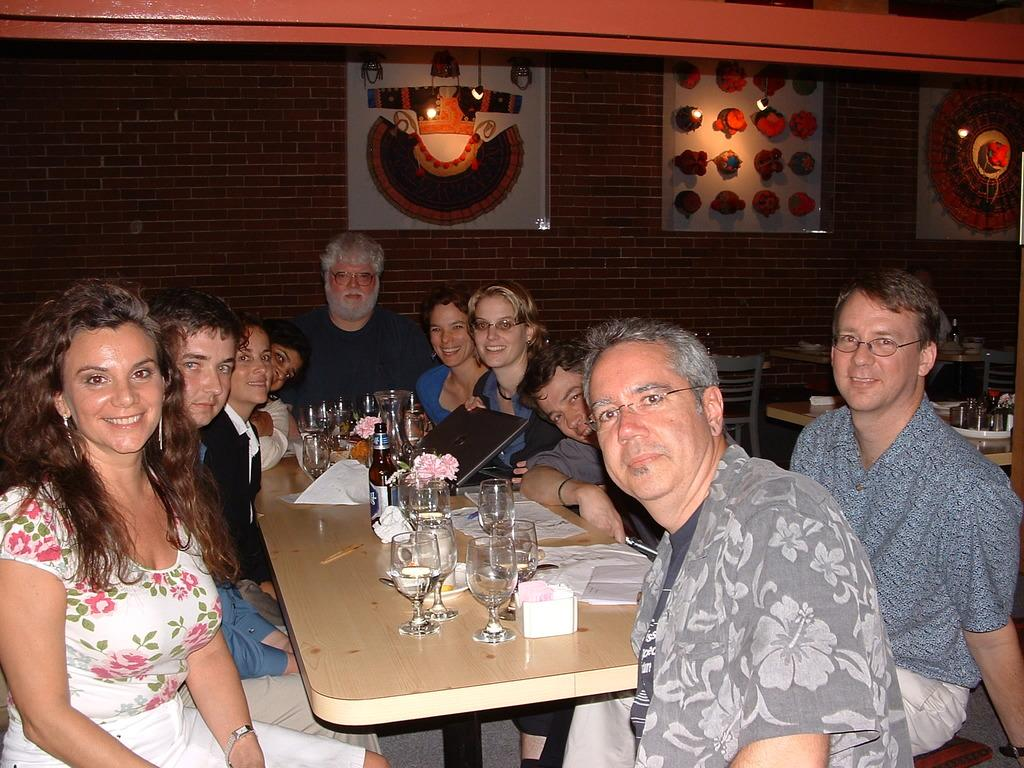How many people are in the image? There is a group of people in the image, but the exact number cannot be determined from the provided facts. What are the people doing in the image? The people are sitting around a table in the image. What items can be seen on the table? There are glasses, tissues, and a laptop on the table. What is hanging decorations are visible in the image? There are frames on the wall in the image. What type of brick is used to construct the moon in the image? There is no moon or brick present in the image. How does friction affect the movement of the laptop on the table? The provided facts do not mention any movement of the laptop, so it is not possible to determine the effect of friction on its movement. 